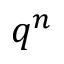<formula> <loc_0><loc_0><loc_500><loc_500>q ^ { n }</formula> 